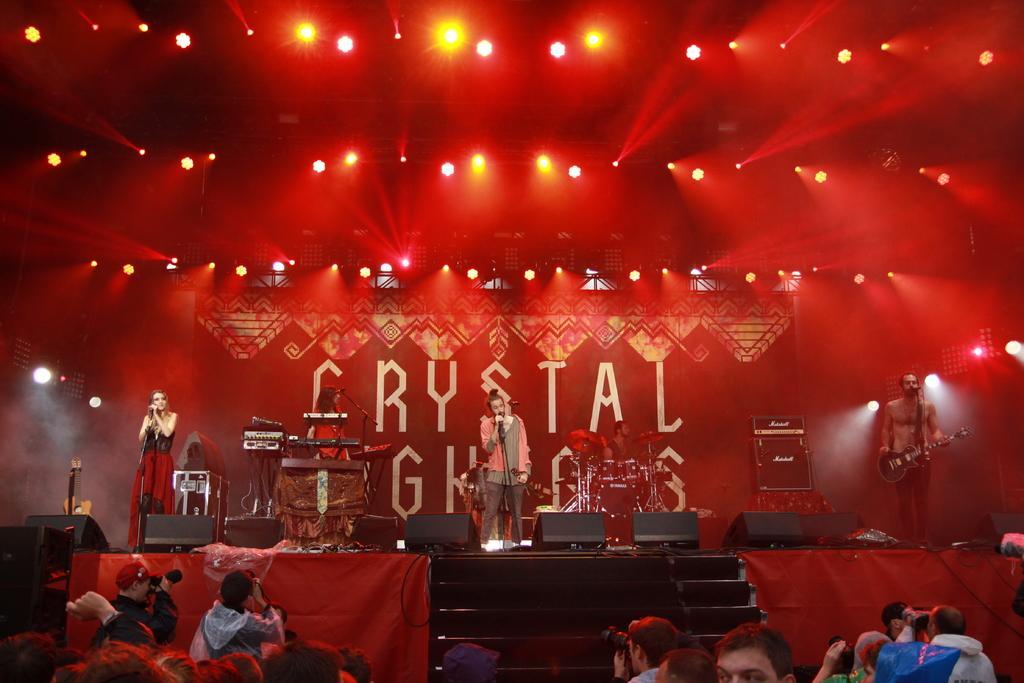In one or two sentences, can you explain what this image depicts? In this image, we can see few people are on the stage. Here there are few stands, black boxes, musical instruments. Background there is a banner. Top of the image, we can see the lights. At the bottom of the image, we can see stairs, clothes, a group of people. Few people are holding cameras. 